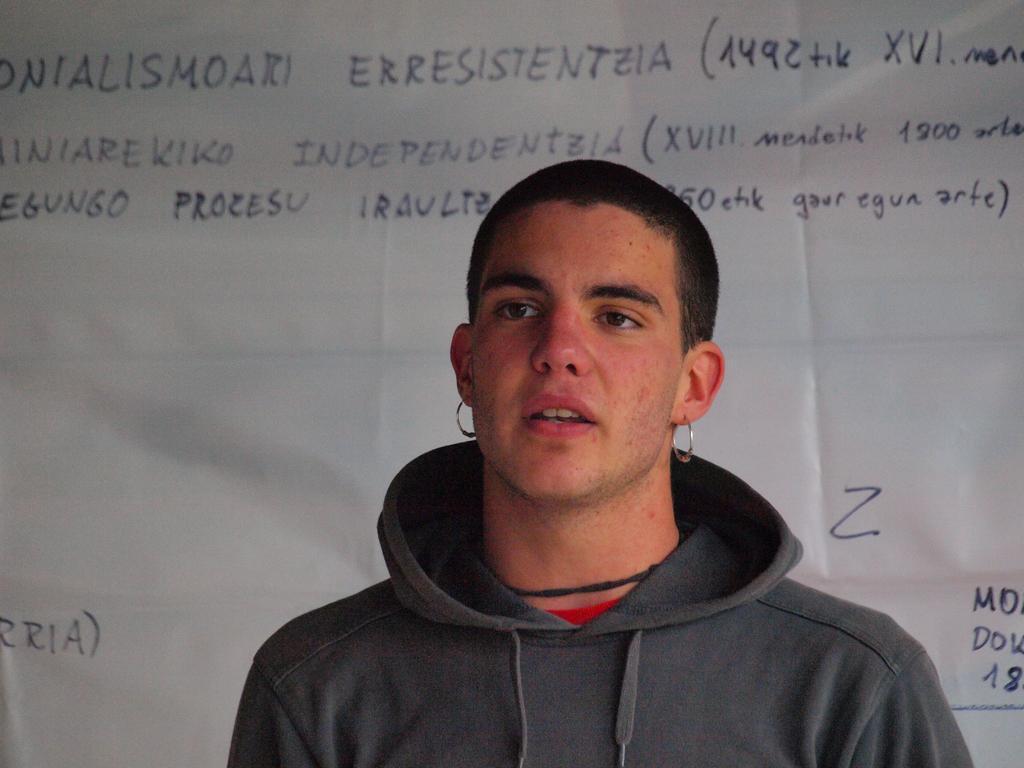In one or two sentences, can you explain what this image depicts? In this image we can see a person is standing, he is wearing the jacket, at back here is the banner, and some matter written on it. 